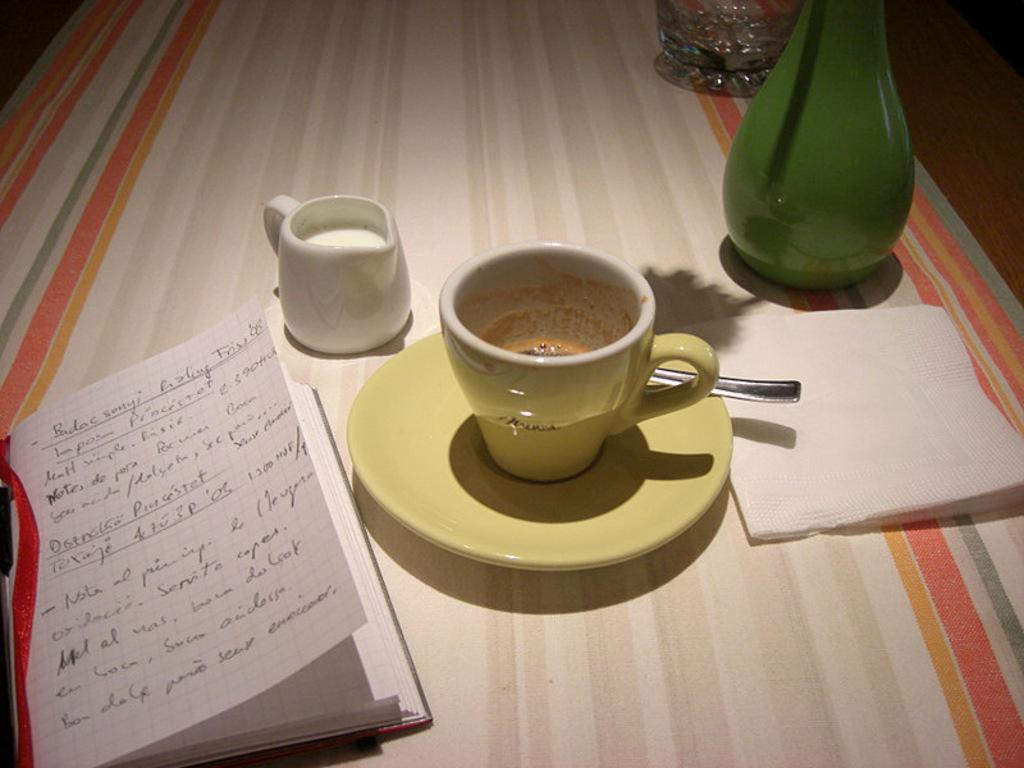What piece of furniture is present in the image? There is a table in the image. What object can be seen on the table? There is a book and a milk jug on the table. What type of beverage container is present in the image? There is a tea cup on the table. What design is featured on the tea cup? The tea cup has a soccer design. What item is placed beside the tea cup? There is a napkin beside the tea cup. What type of crime is being committed in the image? There is no crime being committed in the image; it features a table with various objects on it. 